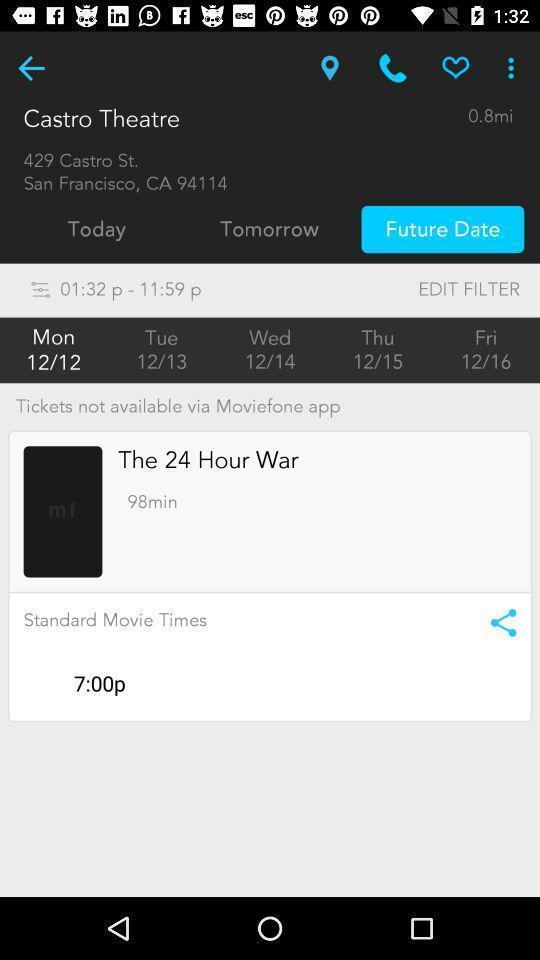Describe the content in this image. Tickets not available in the app. 